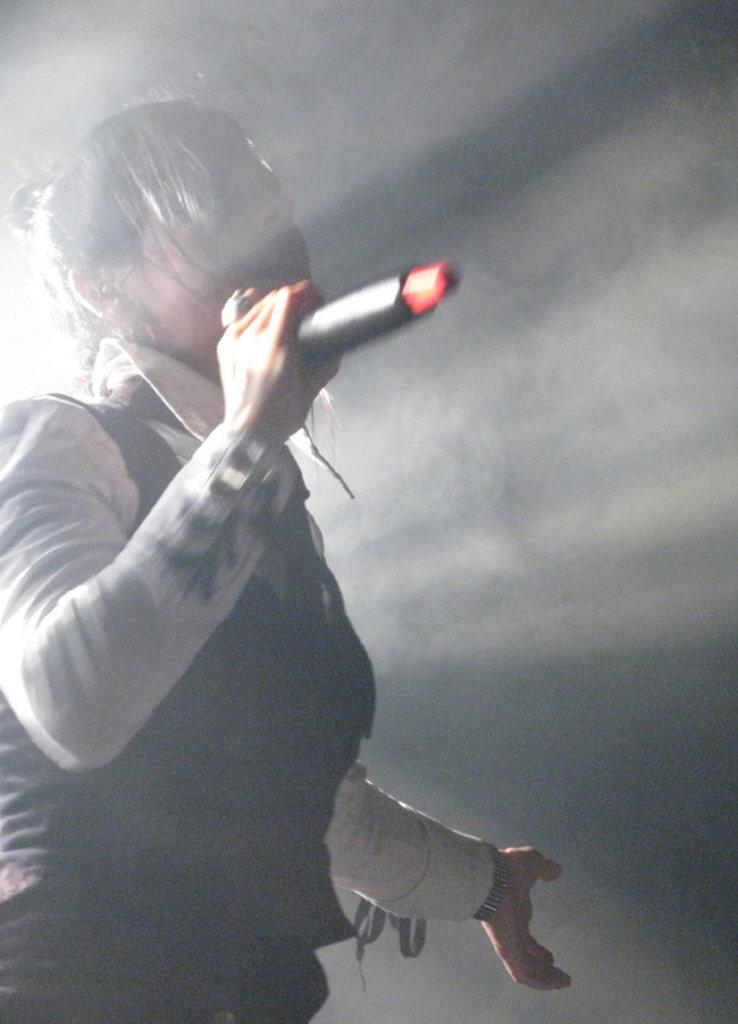What is the main subject of the image? There is a person in the image. What is the person doing in the image? The person is standing and singing a song. What object is the person holding in their hand? The person is holding a microphone in their hand. What type of rice can be seen in the image? There is no rice present in the image. How many farmers are visible in the image? There are no farmers present in the image. What kind of flock is gathered around the person in the image? There is no flock present in the image. 